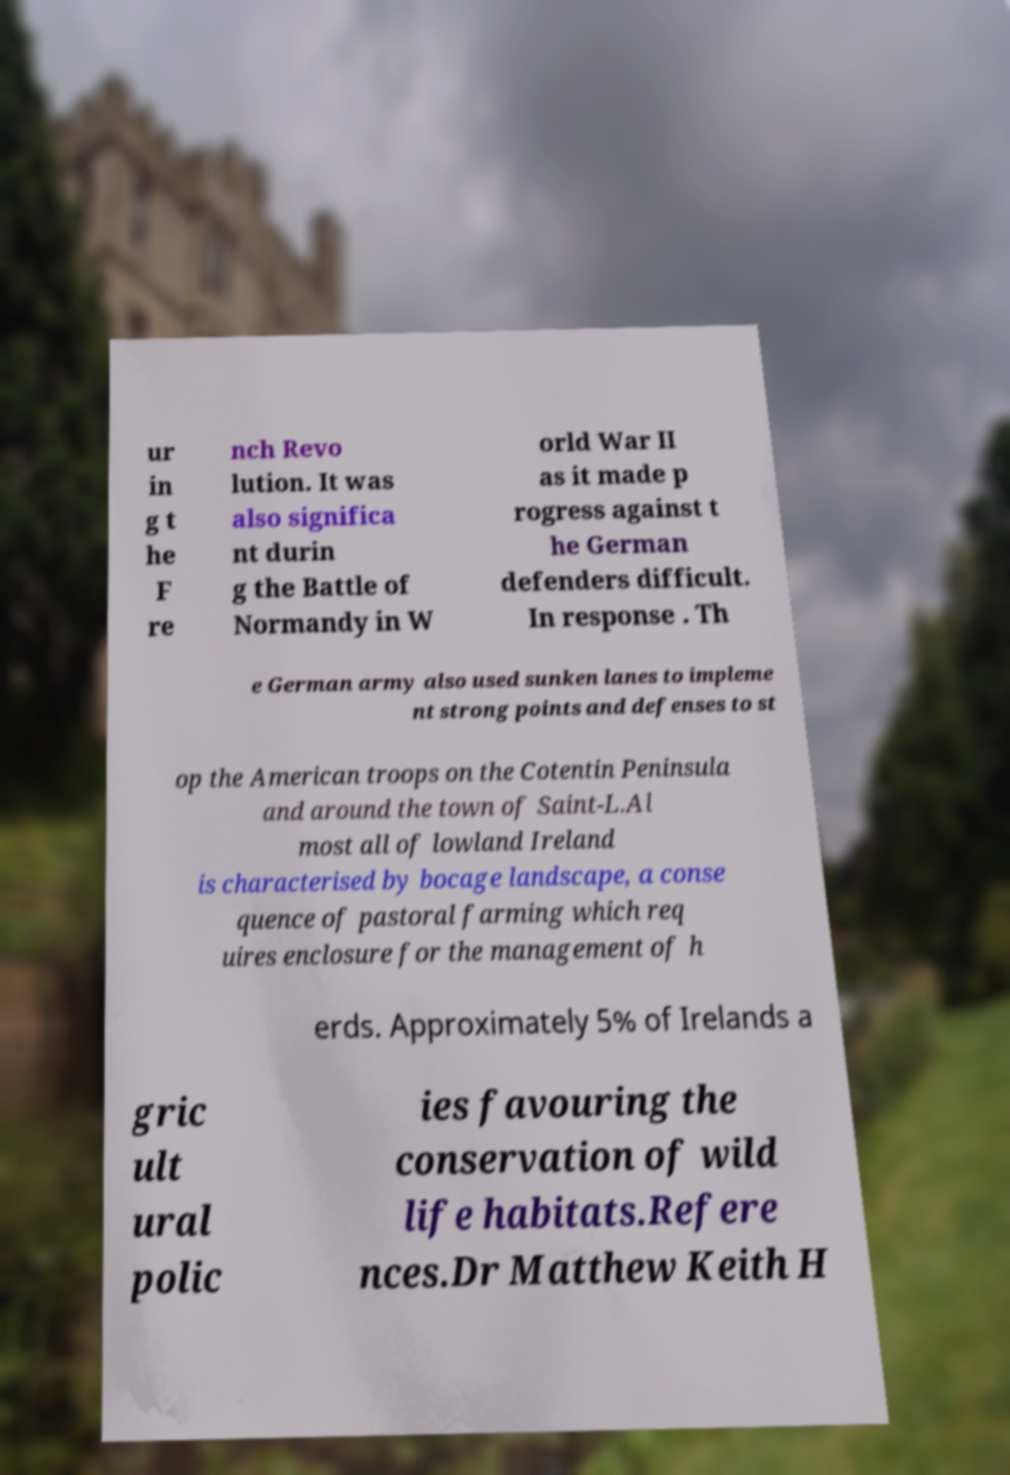For documentation purposes, I need the text within this image transcribed. Could you provide that? ur in g t he F re nch Revo lution. It was also significa nt durin g the Battle of Normandy in W orld War II as it made p rogress against t he German defenders difficult. In response . Th e German army also used sunken lanes to impleme nt strong points and defenses to st op the American troops on the Cotentin Peninsula and around the town of Saint-L.Al most all of lowland Ireland is characterised by bocage landscape, a conse quence of pastoral farming which req uires enclosure for the management of h erds. Approximately 5% of Irelands a gric ult ural polic ies favouring the conservation of wild life habitats.Refere nces.Dr Matthew Keith H 